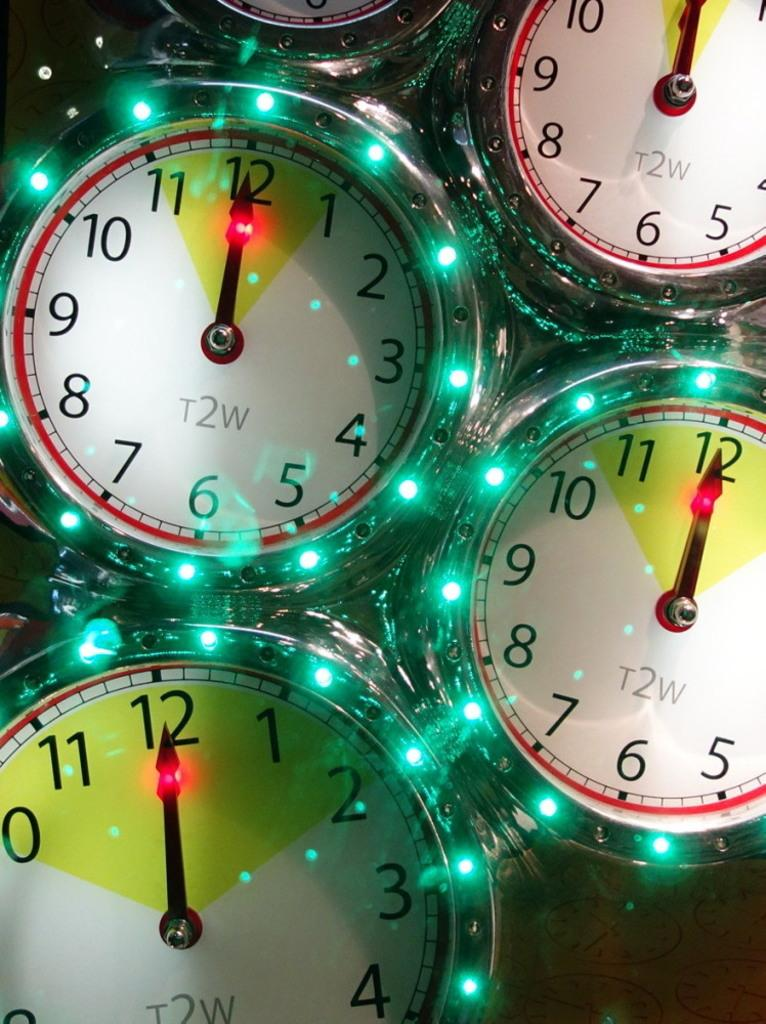<image>
Provide a brief description of the given image. Four faces of a clock have t2w in the middle and the time of 12:00. 